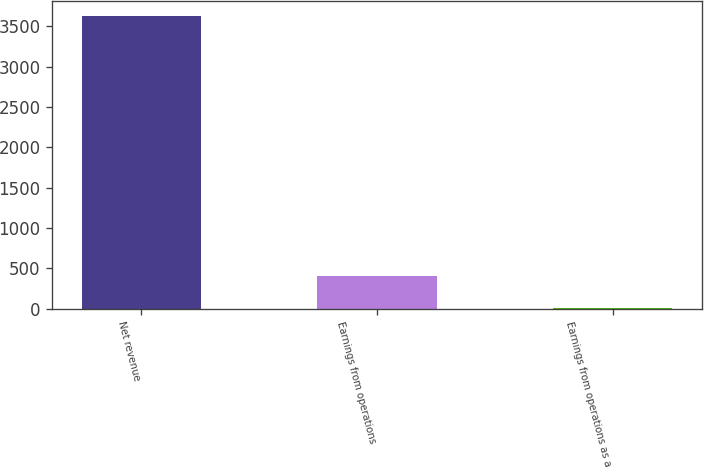<chart> <loc_0><loc_0><loc_500><loc_500><bar_chart><fcel>Net revenue<fcel>Earnings from operations<fcel>Earnings from operations as a<nl><fcel>3629<fcel>399<fcel>11<nl></chart> 